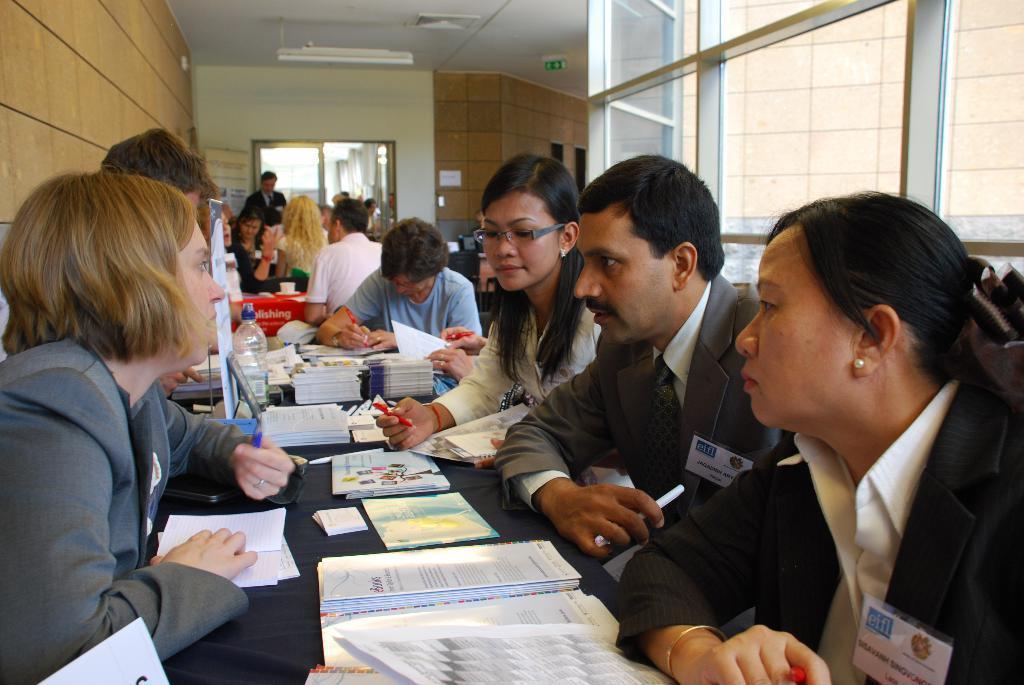How would you summarize this image in a sentence or two? In this image there are a few people sitting and standing in front of the tables, on the tables there are books, papers, water bottles and a few other objects. On the right side of the image there is a glass wall, on the left side of the image there is a wall. In the background there is a wall with a door. At the top of the image there is a ceiling. 